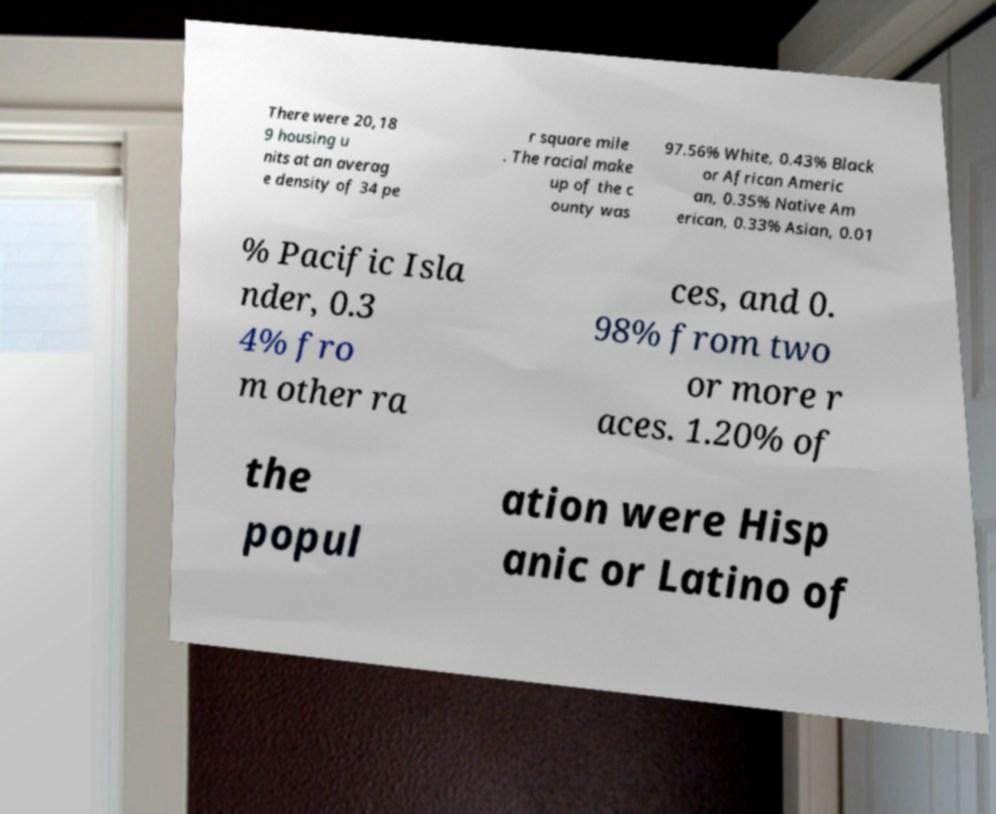What messages or text are displayed in this image? I need them in a readable, typed format. There were 20,18 9 housing u nits at an averag e density of 34 pe r square mile . The racial make up of the c ounty was 97.56% White, 0.43% Black or African Americ an, 0.35% Native Am erican, 0.33% Asian, 0.01 % Pacific Isla nder, 0.3 4% fro m other ra ces, and 0. 98% from two or more r aces. 1.20% of the popul ation were Hisp anic or Latino of 